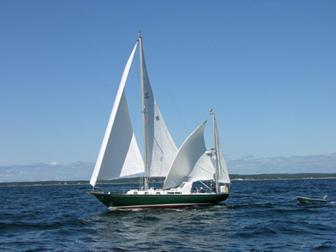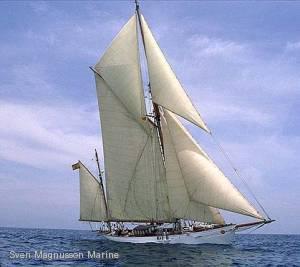The first image is the image on the left, the second image is the image on the right. Given the left and right images, does the statement "Exactly two people are visible and seated in a boat with a wood interior." hold true? Answer yes or no. No. The first image is the image on the left, the second image is the image on the right. For the images shown, is this caption "There is a person in a red coat in one of the images" true? Answer yes or no. No. 